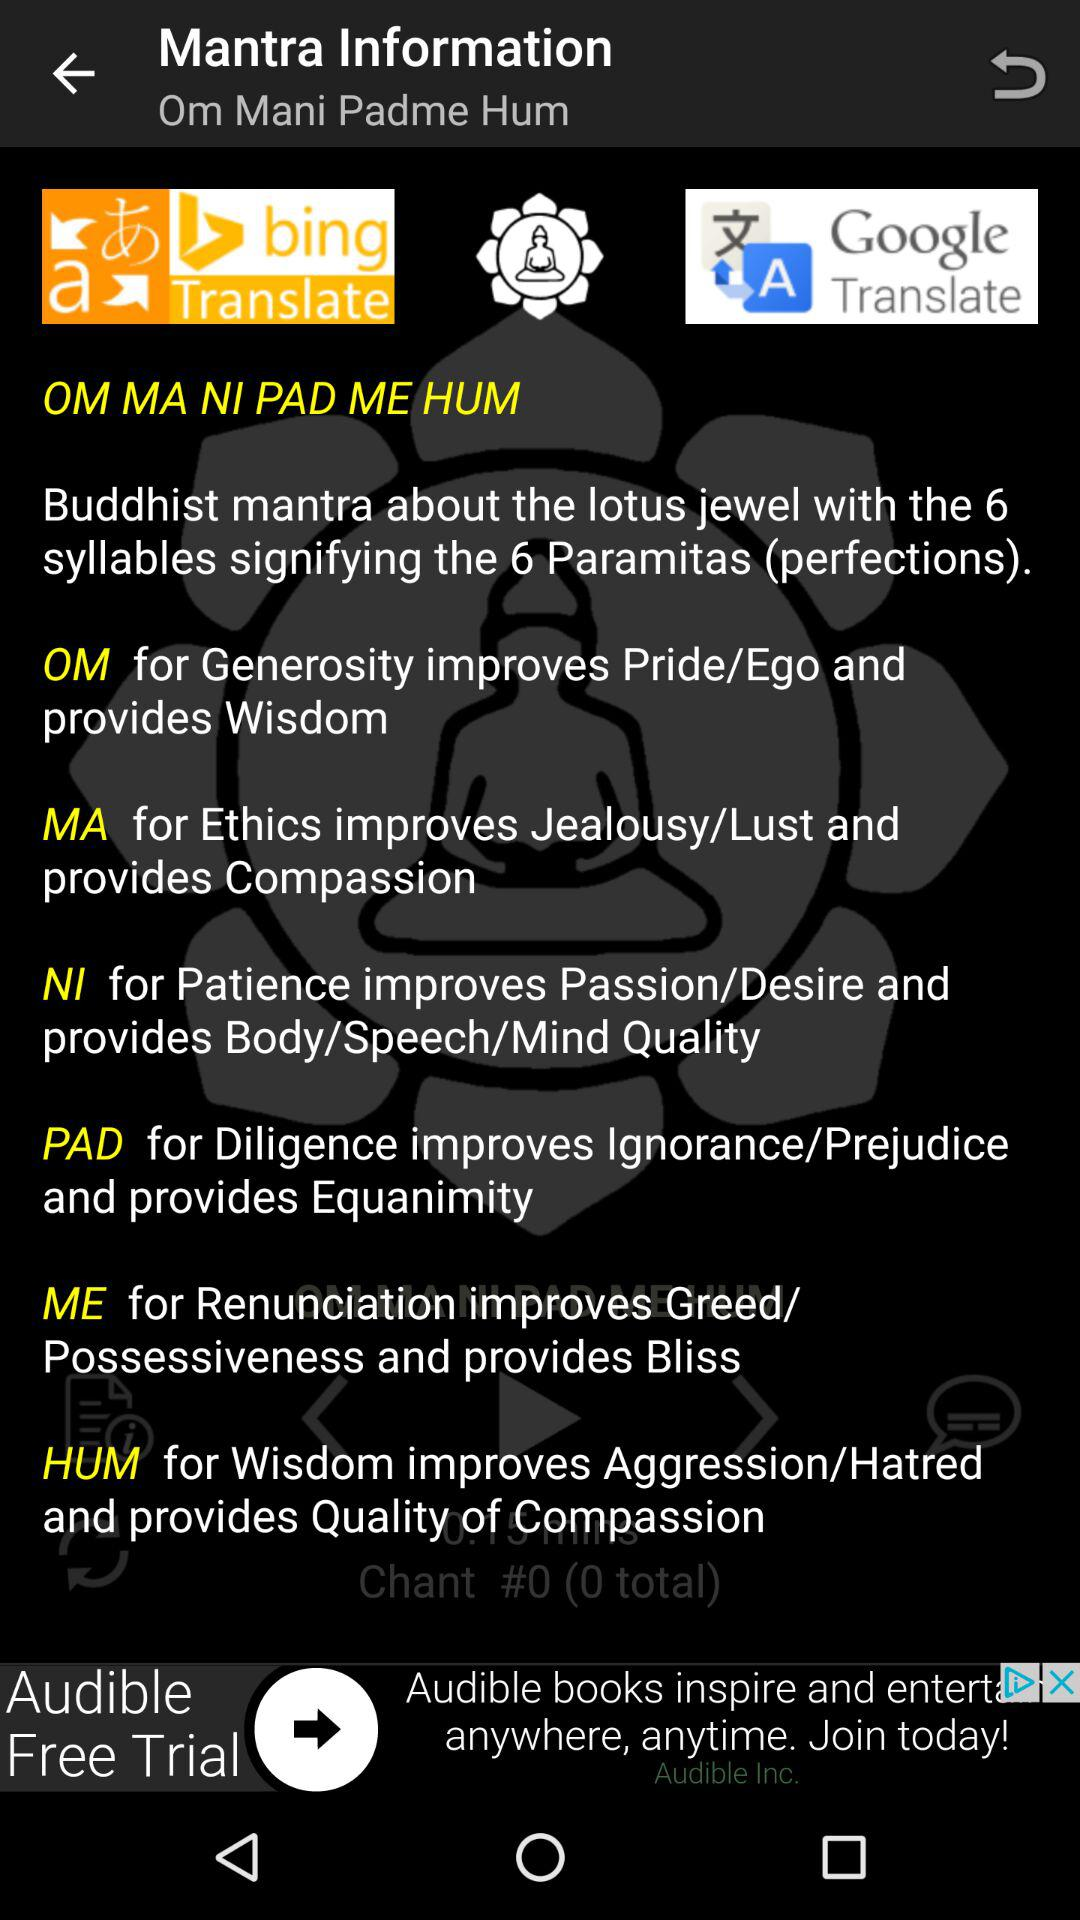What does the "OM" mantra stand for?
Answer the question using a single word or phrase. It stand for "Generosity improves pride/ego and provides wisdom" 